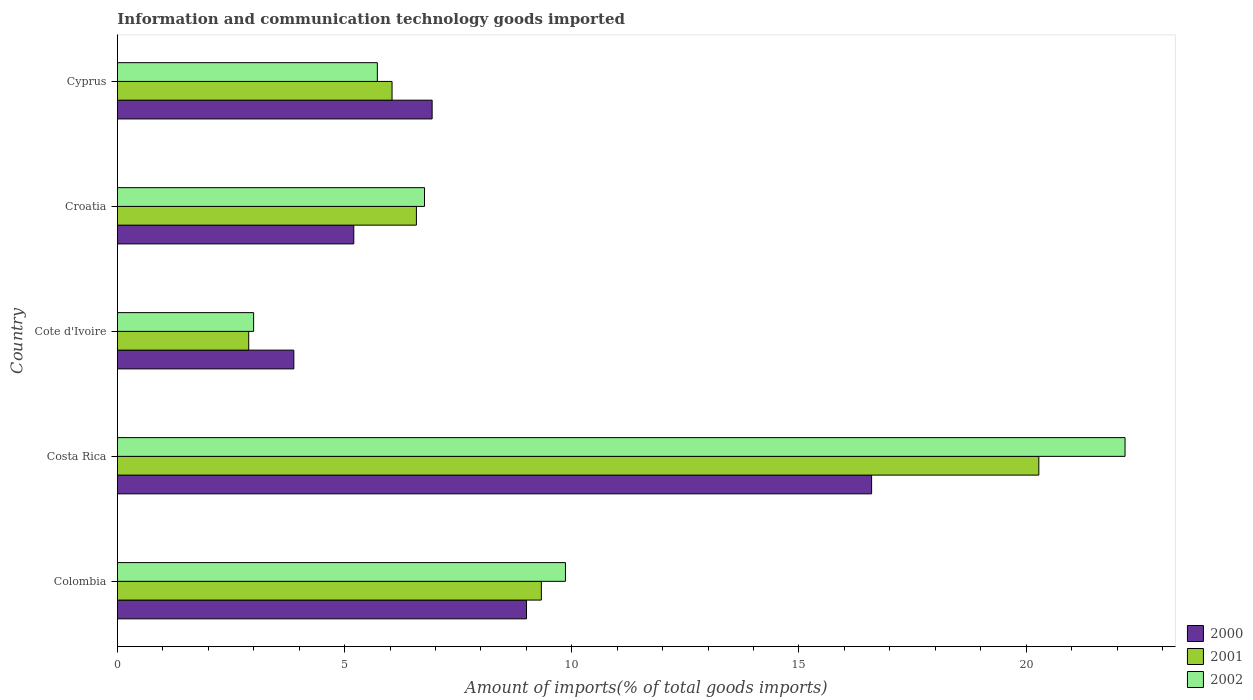How many different coloured bars are there?
Ensure brevity in your answer.  3. Are the number of bars per tick equal to the number of legend labels?
Ensure brevity in your answer.  Yes. Are the number of bars on each tick of the Y-axis equal?
Offer a very short reply. Yes. What is the label of the 1st group of bars from the top?
Offer a very short reply. Cyprus. In how many cases, is the number of bars for a given country not equal to the number of legend labels?
Give a very brief answer. 0. What is the amount of goods imported in 2000 in Colombia?
Ensure brevity in your answer.  9. Across all countries, what is the maximum amount of goods imported in 2000?
Your answer should be compact. 16.6. Across all countries, what is the minimum amount of goods imported in 2000?
Make the answer very short. 3.88. In which country was the amount of goods imported in 2002 maximum?
Give a very brief answer. Costa Rica. In which country was the amount of goods imported in 2001 minimum?
Make the answer very short. Cote d'Ivoire. What is the total amount of goods imported in 2001 in the graph?
Your response must be concise. 45.12. What is the difference between the amount of goods imported in 2001 in Cote d'Ivoire and that in Croatia?
Your answer should be compact. -3.69. What is the difference between the amount of goods imported in 2000 in Cote d'Ivoire and the amount of goods imported in 2002 in Costa Rica?
Your answer should be compact. -18.29. What is the average amount of goods imported in 2000 per country?
Your answer should be compact. 8.32. What is the difference between the amount of goods imported in 2001 and amount of goods imported in 2000 in Cote d'Ivoire?
Ensure brevity in your answer.  -0.99. What is the ratio of the amount of goods imported in 2002 in Colombia to that in Cyprus?
Your answer should be compact. 1.72. Is the amount of goods imported in 2001 in Croatia less than that in Cyprus?
Provide a short and direct response. No. What is the difference between the highest and the second highest amount of goods imported in 2001?
Provide a short and direct response. 10.95. What is the difference between the highest and the lowest amount of goods imported in 2001?
Provide a succinct answer. 17.39. Is the sum of the amount of goods imported in 2000 in Colombia and Cote d'Ivoire greater than the maximum amount of goods imported in 2002 across all countries?
Give a very brief answer. No. What does the 2nd bar from the bottom in Colombia represents?
Your response must be concise. 2001. Is it the case that in every country, the sum of the amount of goods imported in 2001 and amount of goods imported in 2000 is greater than the amount of goods imported in 2002?
Your response must be concise. Yes. How many bars are there?
Offer a very short reply. 15. Are all the bars in the graph horizontal?
Provide a short and direct response. Yes. How many countries are there in the graph?
Keep it short and to the point. 5. Are the values on the major ticks of X-axis written in scientific E-notation?
Provide a short and direct response. No. Does the graph contain any zero values?
Give a very brief answer. No. Does the graph contain grids?
Give a very brief answer. No. Where does the legend appear in the graph?
Offer a very short reply. Bottom right. How are the legend labels stacked?
Give a very brief answer. Vertical. What is the title of the graph?
Your response must be concise. Information and communication technology goods imported. What is the label or title of the X-axis?
Your response must be concise. Amount of imports(% of total goods imports). What is the Amount of imports(% of total goods imports) in 2000 in Colombia?
Give a very brief answer. 9. What is the Amount of imports(% of total goods imports) in 2001 in Colombia?
Offer a terse response. 9.33. What is the Amount of imports(% of total goods imports) in 2002 in Colombia?
Provide a succinct answer. 9.86. What is the Amount of imports(% of total goods imports) in 2000 in Costa Rica?
Give a very brief answer. 16.6. What is the Amount of imports(% of total goods imports) in 2001 in Costa Rica?
Offer a very short reply. 20.28. What is the Amount of imports(% of total goods imports) in 2002 in Costa Rica?
Ensure brevity in your answer.  22.18. What is the Amount of imports(% of total goods imports) of 2000 in Cote d'Ivoire?
Provide a short and direct response. 3.88. What is the Amount of imports(% of total goods imports) of 2001 in Cote d'Ivoire?
Provide a short and direct response. 2.89. What is the Amount of imports(% of total goods imports) in 2002 in Cote d'Ivoire?
Ensure brevity in your answer.  3. What is the Amount of imports(% of total goods imports) of 2000 in Croatia?
Offer a terse response. 5.2. What is the Amount of imports(% of total goods imports) of 2001 in Croatia?
Your answer should be very brief. 6.58. What is the Amount of imports(% of total goods imports) in 2002 in Croatia?
Provide a short and direct response. 6.76. What is the Amount of imports(% of total goods imports) of 2000 in Cyprus?
Provide a short and direct response. 6.93. What is the Amount of imports(% of total goods imports) of 2001 in Cyprus?
Give a very brief answer. 6.04. What is the Amount of imports(% of total goods imports) of 2002 in Cyprus?
Offer a terse response. 5.72. Across all countries, what is the maximum Amount of imports(% of total goods imports) of 2000?
Offer a terse response. 16.6. Across all countries, what is the maximum Amount of imports(% of total goods imports) of 2001?
Your answer should be compact. 20.28. Across all countries, what is the maximum Amount of imports(% of total goods imports) in 2002?
Your answer should be very brief. 22.18. Across all countries, what is the minimum Amount of imports(% of total goods imports) in 2000?
Your answer should be compact. 3.88. Across all countries, what is the minimum Amount of imports(% of total goods imports) in 2001?
Offer a terse response. 2.89. Across all countries, what is the minimum Amount of imports(% of total goods imports) of 2002?
Offer a very short reply. 3. What is the total Amount of imports(% of total goods imports) of 2000 in the graph?
Your answer should be very brief. 41.61. What is the total Amount of imports(% of total goods imports) of 2001 in the graph?
Give a very brief answer. 45.12. What is the total Amount of imports(% of total goods imports) in 2002 in the graph?
Your answer should be compact. 47.52. What is the difference between the Amount of imports(% of total goods imports) of 2000 in Colombia and that in Costa Rica?
Give a very brief answer. -7.59. What is the difference between the Amount of imports(% of total goods imports) in 2001 in Colombia and that in Costa Rica?
Your answer should be compact. -10.95. What is the difference between the Amount of imports(% of total goods imports) of 2002 in Colombia and that in Costa Rica?
Make the answer very short. -12.32. What is the difference between the Amount of imports(% of total goods imports) in 2000 in Colombia and that in Cote d'Ivoire?
Your response must be concise. 5.12. What is the difference between the Amount of imports(% of total goods imports) in 2001 in Colombia and that in Cote d'Ivoire?
Give a very brief answer. 6.44. What is the difference between the Amount of imports(% of total goods imports) in 2002 in Colombia and that in Cote d'Ivoire?
Your answer should be very brief. 6.86. What is the difference between the Amount of imports(% of total goods imports) in 2000 in Colombia and that in Croatia?
Your response must be concise. 3.8. What is the difference between the Amount of imports(% of total goods imports) in 2001 in Colombia and that in Croatia?
Provide a succinct answer. 2.75. What is the difference between the Amount of imports(% of total goods imports) of 2002 in Colombia and that in Croatia?
Ensure brevity in your answer.  3.1. What is the difference between the Amount of imports(% of total goods imports) in 2000 in Colombia and that in Cyprus?
Provide a short and direct response. 2.08. What is the difference between the Amount of imports(% of total goods imports) of 2001 in Colombia and that in Cyprus?
Ensure brevity in your answer.  3.29. What is the difference between the Amount of imports(% of total goods imports) in 2002 in Colombia and that in Cyprus?
Give a very brief answer. 4.14. What is the difference between the Amount of imports(% of total goods imports) in 2000 in Costa Rica and that in Cote d'Ivoire?
Provide a succinct answer. 12.72. What is the difference between the Amount of imports(% of total goods imports) of 2001 in Costa Rica and that in Cote d'Ivoire?
Your response must be concise. 17.39. What is the difference between the Amount of imports(% of total goods imports) in 2002 in Costa Rica and that in Cote d'Ivoire?
Offer a terse response. 19.18. What is the difference between the Amount of imports(% of total goods imports) of 2000 in Costa Rica and that in Croatia?
Provide a short and direct response. 11.4. What is the difference between the Amount of imports(% of total goods imports) in 2001 in Costa Rica and that in Croatia?
Provide a succinct answer. 13.7. What is the difference between the Amount of imports(% of total goods imports) of 2002 in Costa Rica and that in Croatia?
Provide a succinct answer. 15.42. What is the difference between the Amount of imports(% of total goods imports) of 2000 in Costa Rica and that in Cyprus?
Keep it short and to the point. 9.67. What is the difference between the Amount of imports(% of total goods imports) of 2001 in Costa Rica and that in Cyprus?
Offer a very short reply. 14.23. What is the difference between the Amount of imports(% of total goods imports) in 2002 in Costa Rica and that in Cyprus?
Give a very brief answer. 16.46. What is the difference between the Amount of imports(% of total goods imports) in 2000 in Cote d'Ivoire and that in Croatia?
Offer a terse response. -1.32. What is the difference between the Amount of imports(% of total goods imports) in 2001 in Cote d'Ivoire and that in Croatia?
Make the answer very short. -3.69. What is the difference between the Amount of imports(% of total goods imports) of 2002 in Cote d'Ivoire and that in Croatia?
Your answer should be compact. -3.76. What is the difference between the Amount of imports(% of total goods imports) of 2000 in Cote d'Ivoire and that in Cyprus?
Offer a terse response. -3.04. What is the difference between the Amount of imports(% of total goods imports) in 2001 in Cote d'Ivoire and that in Cyprus?
Ensure brevity in your answer.  -3.15. What is the difference between the Amount of imports(% of total goods imports) in 2002 in Cote d'Ivoire and that in Cyprus?
Ensure brevity in your answer.  -2.72. What is the difference between the Amount of imports(% of total goods imports) in 2000 in Croatia and that in Cyprus?
Give a very brief answer. -1.72. What is the difference between the Amount of imports(% of total goods imports) in 2001 in Croatia and that in Cyprus?
Offer a very short reply. 0.54. What is the difference between the Amount of imports(% of total goods imports) of 2002 in Croatia and that in Cyprus?
Your answer should be compact. 1.04. What is the difference between the Amount of imports(% of total goods imports) in 2000 in Colombia and the Amount of imports(% of total goods imports) in 2001 in Costa Rica?
Your answer should be compact. -11.28. What is the difference between the Amount of imports(% of total goods imports) of 2000 in Colombia and the Amount of imports(% of total goods imports) of 2002 in Costa Rica?
Keep it short and to the point. -13.17. What is the difference between the Amount of imports(% of total goods imports) of 2001 in Colombia and the Amount of imports(% of total goods imports) of 2002 in Costa Rica?
Your answer should be very brief. -12.85. What is the difference between the Amount of imports(% of total goods imports) of 2000 in Colombia and the Amount of imports(% of total goods imports) of 2001 in Cote d'Ivoire?
Your answer should be compact. 6.11. What is the difference between the Amount of imports(% of total goods imports) of 2000 in Colombia and the Amount of imports(% of total goods imports) of 2002 in Cote d'Ivoire?
Offer a terse response. 6.01. What is the difference between the Amount of imports(% of total goods imports) in 2001 in Colombia and the Amount of imports(% of total goods imports) in 2002 in Cote d'Ivoire?
Make the answer very short. 6.33. What is the difference between the Amount of imports(% of total goods imports) of 2000 in Colombia and the Amount of imports(% of total goods imports) of 2001 in Croatia?
Keep it short and to the point. 2.42. What is the difference between the Amount of imports(% of total goods imports) in 2000 in Colombia and the Amount of imports(% of total goods imports) in 2002 in Croatia?
Your answer should be very brief. 2.25. What is the difference between the Amount of imports(% of total goods imports) in 2001 in Colombia and the Amount of imports(% of total goods imports) in 2002 in Croatia?
Make the answer very short. 2.57. What is the difference between the Amount of imports(% of total goods imports) of 2000 in Colombia and the Amount of imports(% of total goods imports) of 2001 in Cyprus?
Provide a short and direct response. 2.96. What is the difference between the Amount of imports(% of total goods imports) of 2000 in Colombia and the Amount of imports(% of total goods imports) of 2002 in Cyprus?
Provide a succinct answer. 3.28. What is the difference between the Amount of imports(% of total goods imports) in 2001 in Colombia and the Amount of imports(% of total goods imports) in 2002 in Cyprus?
Keep it short and to the point. 3.61. What is the difference between the Amount of imports(% of total goods imports) in 2000 in Costa Rica and the Amount of imports(% of total goods imports) in 2001 in Cote d'Ivoire?
Make the answer very short. 13.71. What is the difference between the Amount of imports(% of total goods imports) of 2000 in Costa Rica and the Amount of imports(% of total goods imports) of 2002 in Cote d'Ivoire?
Keep it short and to the point. 13.6. What is the difference between the Amount of imports(% of total goods imports) in 2001 in Costa Rica and the Amount of imports(% of total goods imports) in 2002 in Cote d'Ivoire?
Provide a short and direct response. 17.28. What is the difference between the Amount of imports(% of total goods imports) in 2000 in Costa Rica and the Amount of imports(% of total goods imports) in 2001 in Croatia?
Keep it short and to the point. 10.02. What is the difference between the Amount of imports(% of total goods imports) in 2000 in Costa Rica and the Amount of imports(% of total goods imports) in 2002 in Croatia?
Keep it short and to the point. 9.84. What is the difference between the Amount of imports(% of total goods imports) in 2001 in Costa Rica and the Amount of imports(% of total goods imports) in 2002 in Croatia?
Give a very brief answer. 13.52. What is the difference between the Amount of imports(% of total goods imports) of 2000 in Costa Rica and the Amount of imports(% of total goods imports) of 2001 in Cyprus?
Keep it short and to the point. 10.55. What is the difference between the Amount of imports(% of total goods imports) of 2000 in Costa Rica and the Amount of imports(% of total goods imports) of 2002 in Cyprus?
Your answer should be very brief. 10.88. What is the difference between the Amount of imports(% of total goods imports) of 2001 in Costa Rica and the Amount of imports(% of total goods imports) of 2002 in Cyprus?
Offer a terse response. 14.56. What is the difference between the Amount of imports(% of total goods imports) in 2000 in Cote d'Ivoire and the Amount of imports(% of total goods imports) in 2001 in Croatia?
Your answer should be very brief. -2.7. What is the difference between the Amount of imports(% of total goods imports) of 2000 in Cote d'Ivoire and the Amount of imports(% of total goods imports) of 2002 in Croatia?
Your response must be concise. -2.88. What is the difference between the Amount of imports(% of total goods imports) in 2001 in Cote d'Ivoire and the Amount of imports(% of total goods imports) in 2002 in Croatia?
Offer a very short reply. -3.87. What is the difference between the Amount of imports(% of total goods imports) in 2000 in Cote d'Ivoire and the Amount of imports(% of total goods imports) in 2001 in Cyprus?
Your answer should be compact. -2.16. What is the difference between the Amount of imports(% of total goods imports) in 2000 in Cote d'Ivoire and the Amount of imports(% of total goods imports) in 2002 in Cyprus?
Give a very brief answer. -1.84. What is the difference between the Amount of imports(% of total goods imports) of 2001 in Cote d'Ivoire and the Amount of imports(% of total goods imports) of 2002 in Cyprus?
Offer a terse response. -2.83. What is the difference between the Amount of imports(% of total goods imports) of 2000 in Croatia and the Amount of imports(% of total goods imports) of 2001 in Cyprus?
Ensure brevity in your answer.  -0.84. What is the difference between the Amount of imports(% of total goods imports) in 2000 in Croatia and the Amount of imports(% of total goods imports) in 2002 in Cyprus?
Keep it short and to the point. -0.52. What is the difference between the Amount of imports(% of total goods imports) in 2001 in Croatia and the Amount of imports(% of total goods imports) in 2002 in Cyprus?
Offer a very short reply. 0.86. What is the average Amount of imports(% of total goods imports) in 2000 per country?
Offer a very short reply. 8.32. What is the average Amount of imports(% of total goods imports) in 2001 per country?
Your answer should be compact. 9.03. What is the average Amount of imports(% of total goods imports) of 2002 per country?
Offer a very short reply. 9.5. What is the difference between the Amount of imports(% of total goods imports) of 2000 and Amount of imports(% of total goods imports) of 2001 in Colombia?
Give a very brief answer. -0.33. What is the difference between the Amount of imports(% of total goods imports) in 2000 and Amount of imports(% of total goods imports) in 2002 in Colombia?
Your answer should be very brief. -0.86. What is the difference between the Amount of imports(% of total goods imports) of 2001 and Amount of imports(% of total goods imports) of 2002 in Colombia?
Provide a short and direct response. -0.53. What is the difference between the Amount of imports(% of total goods imports) in 2000 and Amount of imports(% of total goods imports) in 2001 in Costa Rica?
Make the answer very short. -3.68. What is the difference between the Amount of imports(% of total goods imports) in 2000 and Amount of imports(% of total goods imports) in 2002 in Costa Rica?
Provide a short and direct response. -5.58. What is the difference between the Amount of imports(% of total goods imports) of 2001 and Amount of imports(% of total goods imports) of 2002 in Costa Rica?
Provide a succinct answer. -1.9. What is the difference between the Amount of imports(% of total goods imports) in 2000 and Amount of imports(% of total goods imports) in 2001 in Cote d'Ivoire?
Your response must be concise. 0.99. What is the difference between the Amount of imports(% of total goods imports) of 2000 and Amount of imports(% of total goods imports) of 2002 in Cote d'Ivoire?
Provide a succinct answer. 0.89. What is the difference between the Amount of imports(% of total goods imports) of 2001 and Amount of imports(% of total goods imports) of 2002 in Cote d'Ivoire?
Provide a short and direct response. -0.11. What is the difference between the Amount of imports(% of total goods imports) of 2000 and Amount of imports(% of total goods imports) of 2001 in Croatia?
Your response must be concise. -1.38. What is the difference between the Amount of imports(% of total goods imports) in 2000 and Amount of imports(% of total goods imports) in 2002 in Croatia?
Offer a terse response. -1.56. What is the difference between the Amount of imports(% of total goods imports) in 2001 and Amount of imports(% of total goods imports) in 2002 in Croatia?
Ensure brevity in your answer.  -0.18. What is the difference between the Amount of imports(% of total goods imports) of 2000 and Amount of imports(% of total goods imports) of 2001 in Cyprus?
Keep it short and to the point. 0.88. What is the difference between the Amount of imports(% of total goods imports) of 2000 and Amount of imports(% of total goods imports) of 2002 in Cyprus?
Make the answer very short. 1.21. What is the difference between the Amount of imports(% of total goods imports) in 2001 and Amount of imports(% of total goods imports) in 2002 in Cyprus?
Provide a succinct answer. 0.32. What is the ratio of the Amount of imports(% of total goods imports) of 2000 in Colombia to that in Costa Rica?
Your response must be concise. 0.54. What is the ratio of the Amount of imports(% of total goods imports) in 2001 in Colombia to that in Costa Rica?
Provide a short and direct response. 0.46. What is the ratio of the Amount of imports(% of total goods imports) in 2002 in Colombia to that in Costa Rica?
Ensure brevity in your answer.  0.44. What is the ratio of the Amount of imports(% of total goods imports) of 2000 in Colombia to that in Cote d'Ivoire?
Provide a succinct answer. 2.32. What is the ratio of the Amount of imports(% of total goods imports) in 2001 in Colombia to that in Cote d'Ivoire?
Keep it short and to the point. 3.23. What is the ratio of the Amount of imports(% of total goods imports) in 2002 in Colombia to that in Cote d'Ivoire?
Offer a very short reply. 3.29. What is the ratio of the Amount of imports(% of total goods imports) in 2000 in Colombia to that in Croatia?
Give a very brief answer. 1.73. What is the ratio of the Amount of imports(% of total goods imports) of 2001 in Colombia to that in Croatia?
Keep it short and to the point. 1.42. What is the ratio of the Amount of imports(% of total goods imports) of 2002 in Colombia to that in Croatia?
Ensure brevity in your answer.  1.46. What is the ratio of the Amount of imports(% of total goods imports) in 2000 in Colombia to that in Cyprus?
Your answer should be very brief. 1.3. What is the ratio of the Amount of imports(% of total goods imports) in 2001 in Colombia to that in Cyprus?
Make the answer very short. 1.54. What is the ratio of the Amount of imports(% of total goods imports) of 2002 in Colombia to that in Cyprus?
Give a very brief answer. 1.72. What is the ratio of the Amount of imports(% of total goods imports) of 2000 in Costa Rica to that in Cote d'Ivoire?
Provide a succinct answer. 4.27. What is the ratio of the Amount of imports(% of total goods imports) in 2001 in Costa Rica to that in Cote d'Ivoire?
Offer a very short reply. 7.02. What is the ratio of the Amount of imports(% of total goods imports) in 2002 in Costa Rica to that in Cote d'Ivoire?
Offer a terse response. 7.4. What is the ratio of the Amount of imports(% of total goods imports) in 2000 in Costa Rica to that in Croatia?
Offer a very short reply. 3.19. What is the ratio of the Amount of imports(% of total goods imports) in 2001 in Costa Rica to that in Croatia?
Offer a terse response. 3.08. What is the ratio of the Amount of imports(% of total goods imports) of 2002 in Costa Rica to that in Croatia?
Provide a succinct answer. 3.28. What is the ratio of the Amount of imports(% of total goods imports) in 2000 in Costa Rica to that in Cyprus?
Your response must be concise. 2.4. What is the ratio of the Amount of imports(% of total goods imports) of 2001 in Costa Rica to that in Cyprus?
Ensure brevity in your answer.  3.35. What is the ratio of the Amount of imports(% of total goods imports) of 2002 in Costa Rica to that in Cyprus?
Your response must be concise. 3.88. What is the ratio of the Amount of imports(% of total goods imports) in 2000 in Cote d'Ivoire to that in Croatia?
Your answer should be very brief. 0.75. What is the ratio of the Amount of imports(% of total goods imports) in 2001 in Cote d'Ivoire to that in Croatia?
Your response must be concise. 0.44. What is the ratio of the Amount of imports(% of total goods imports) of 2002 in Cote d'Ivoire to that in Croatia?
Offer a terse response. 0.44. What is the ratio of the Amount of imports(% of total goods imports) of 2000 in Cote d'Ivoire to that in Cyprus?
Your answer should be compact. 0.56. What is the ratio of the Amount of imports(% of total goods imports) in 2001 in Cote d'Ivoire to that in Cyprus?
Your answer should be very brief. 0.48. What is the ratio of the Amount of imports(% of total goods imports) in 2002 in Cote d'Ivoire to that in Cyprus?
Keep it short and to the point. 0.52. What is the ratio of the Amount of imports(% of total goods imports) of 2000 in Croatia to that in Cyprus?
Keep it short and to the point. 0.75. What is the ratio of the Amount of imports(% of total goods imports) of 2001 in Croatia to that in Cyprus?
Your response must be concise. 1.09. What is the ratio of the Amount of imports(% of total goods imports) of 2002 in Croatia to that in Cyprus?
Your answer should be very brief. 1.18. What is the difference between the highest and the second highest Amount of imports(% of total goods imports) of 2000?
Provide a succinct answer. 7.59. What is the difference between the highest and the second highest Amount of imports(% of total goods imports) of 2001?
Your response must be concise. 10.95. What is the difference between the highest and the second highest Amount of imports(% of total goods imports) in 2002?
Your answer should be compact. 12.32. What is the difference between the highest and the lowest Amount of imports(% of total goods imports) of 2000?
Offer a very short reply. 12.72. What is the difference between the highest and the lowest Amount of imports(% of total goods imports) of 2001?
Your answer should be very brief. 17.39. What is the difference between the highest and the lowest Amount of imports(% of total goods imports) of 2002?
Offer a very short reply. 19.18. 